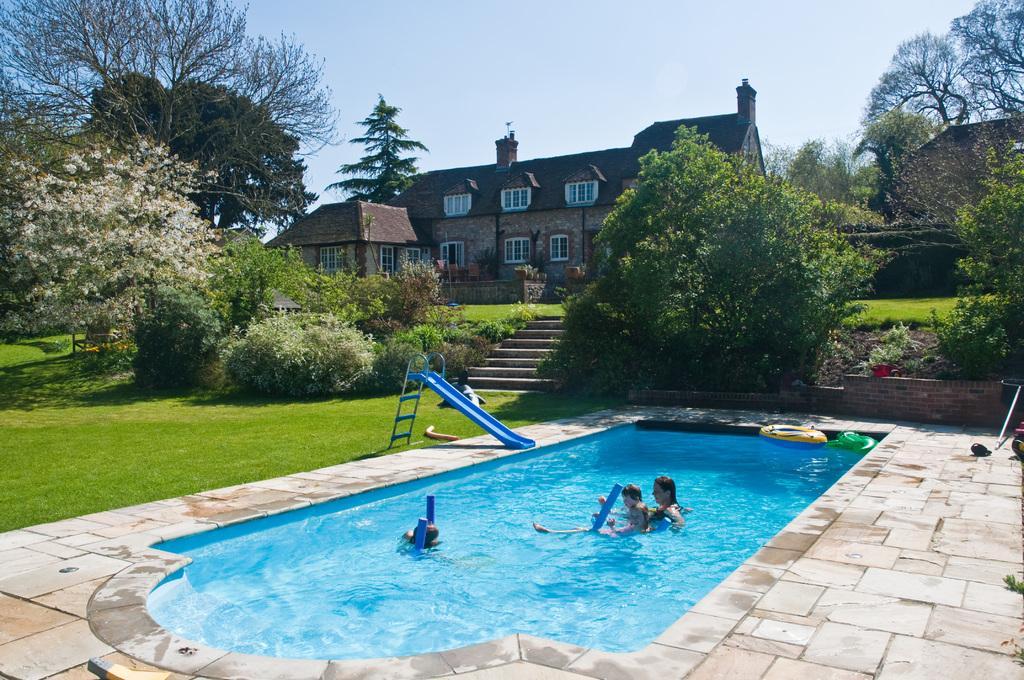Please provide a concise description of this image. In this image we can see a group of people in the swimming pool. In the middle of the image we can see a slide and a staircase. In the background, we can see a building, group of trees and the sky. 